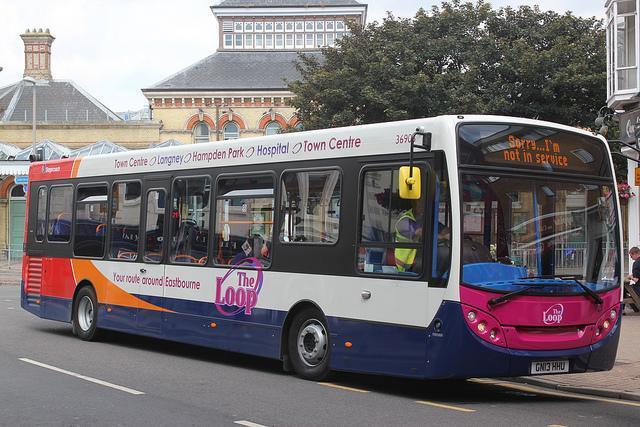How many giraffes are shown?
Give a very brief answer. 0. 